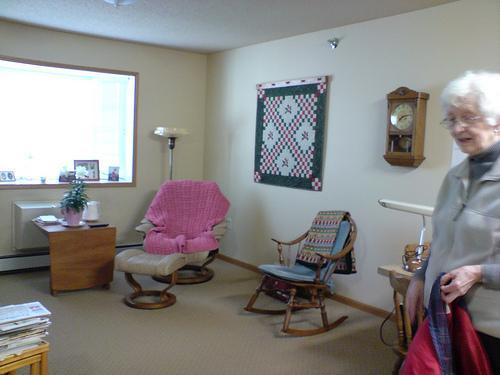How many pink blankets are there?
Give a very brief answer. 1. 